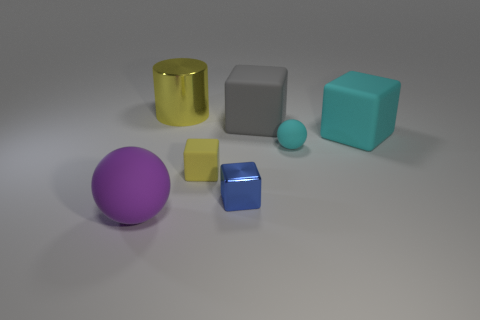What kind of material do these objects look like they're made of? The objects in the image look like they're made of various matte and shiny plastics or synthetic materials, as indicated by their light reflections and smooth surfaces. 